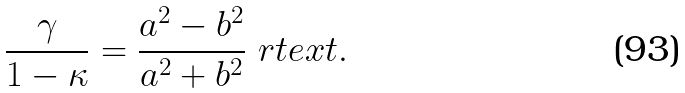<formula> <loc_0><loc_0><loc_500><loc_500>\frac { \gamma } { 1 - \kappa } = \frac { a ^ { 2 } - b ^ { 2 } } { a ^ { 2 } + b ^ { 2 } } \ r t e x t { . }</formula> 